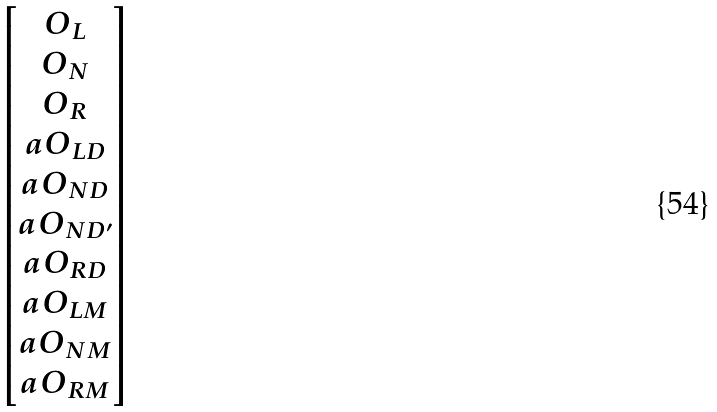Convert formula to latex. <formula><loc_0><loc_0><loc_500><loc_500>\begin{bmatrix} O _ { L } \\ O _ { N } \\ O _ { R } \\ a O _ { L D } \\ a O _ { N D } \\ a O _ { N D ^ { \prime } } \\ a O _ { R D } \\ a O _ { L M } \\ a O _ { N M } \\ a O _ { R M } \end{bmatrix}</formula> 